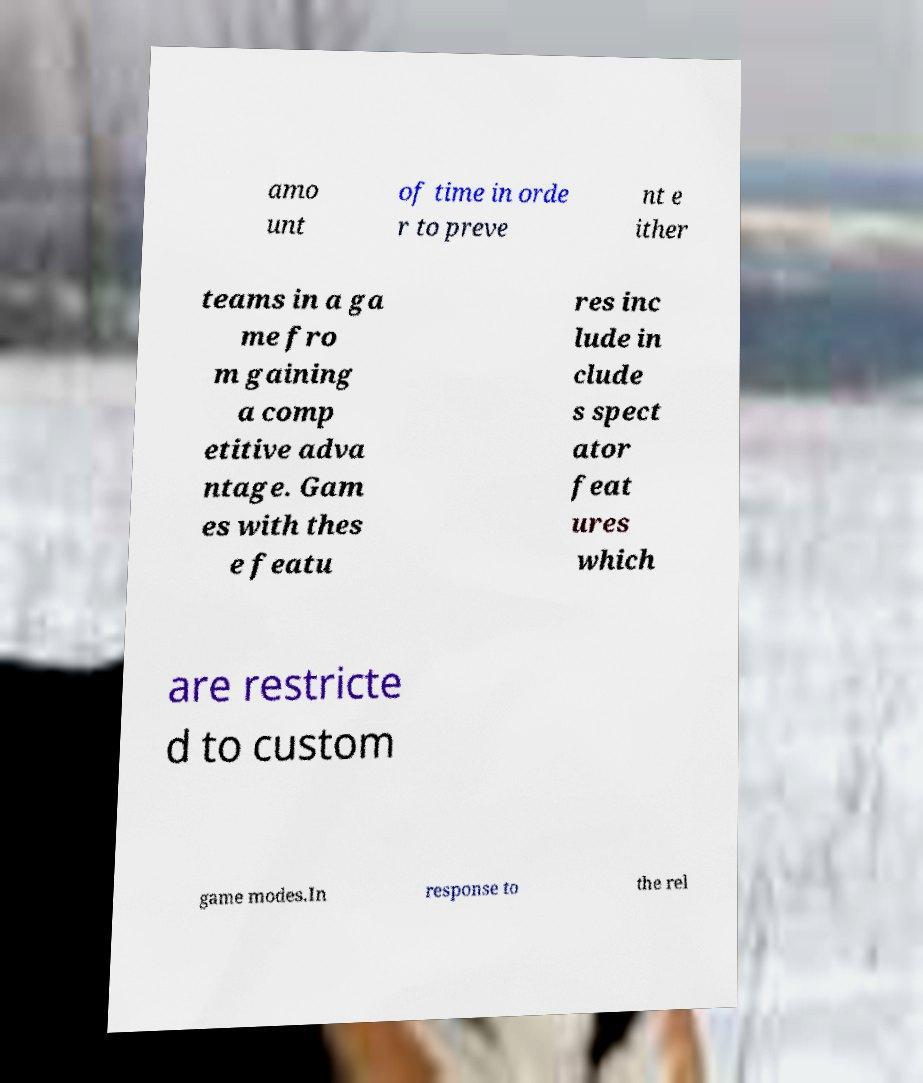Could you assist in decoding the text presented in this image and type it out clearly? amo unt of time in orde r to preve nt e ither teams in a ga me fro m gaining a comp etitive adva ntage. Gam es with thes e featu res inc lude in clude s spect ator feat ures which are restricte d to custom game modes.In response to the rel 